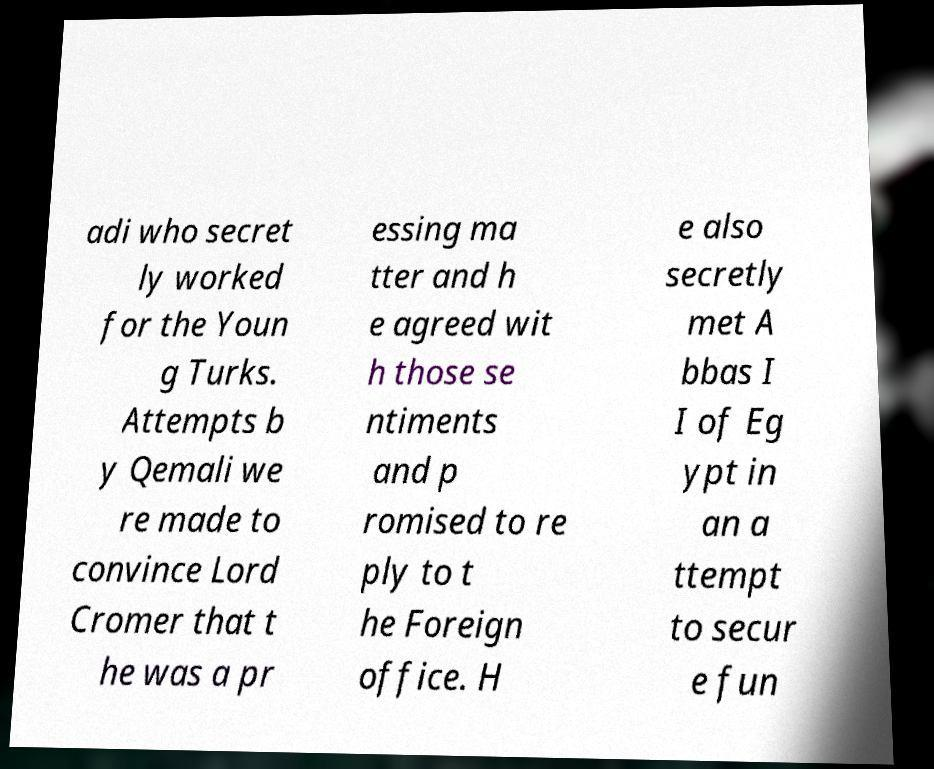There's text embedded in this image that I need extracted. Can you transcribe it verbatim? adi who secret ly worked for the Youn g Turks. Attempts b y Qemali we re made to convince Lord Cromer that t he was a pr essing ma tter and h e agreed wit h those se ntiments and p romised to re ply to t he Foreign office. H e also secretly met A bbas I I of Eg ypt in an a ttempt to secur e fun 